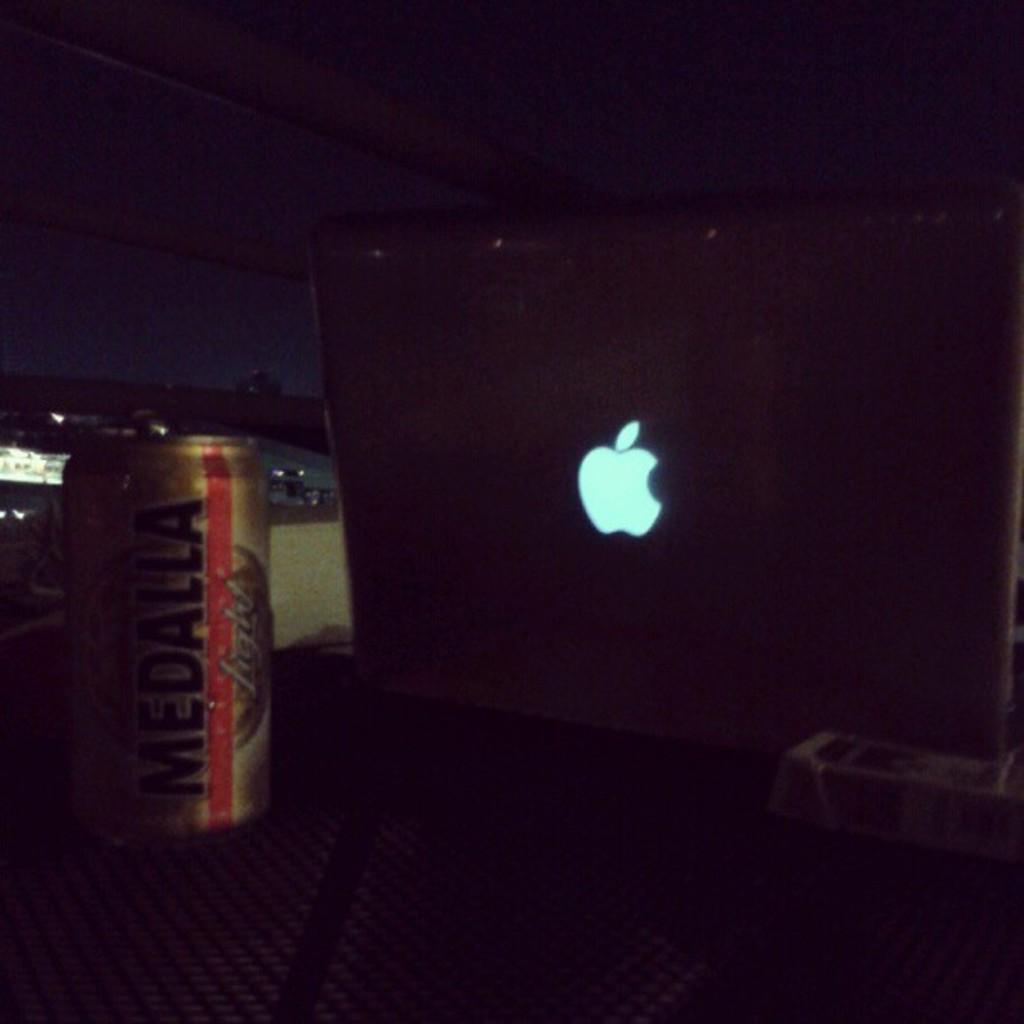What kind of beer is sitting behind the macbook?
Offer a terse response. Medalla. 